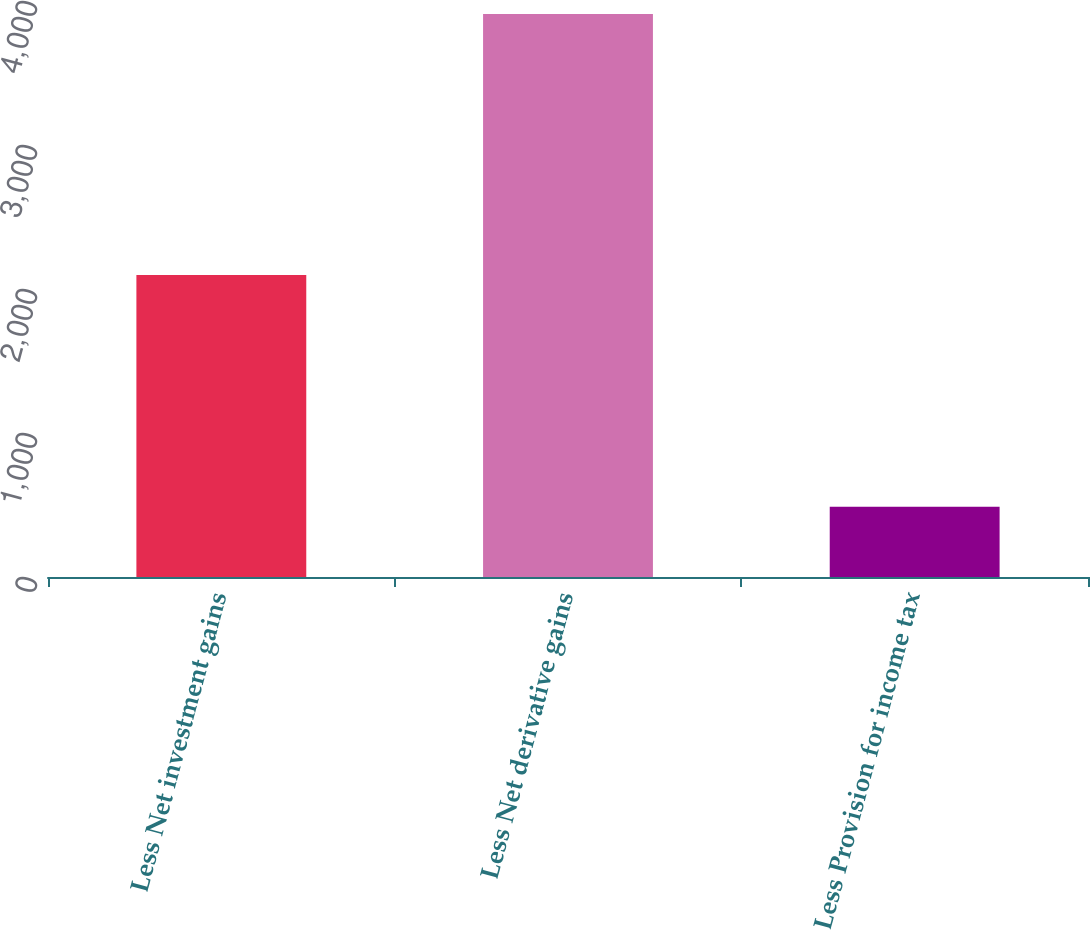Convert chart. <chart><loc_0><loc_0><loc_500><loc_500><bar_chart><fcel>Less Net investment gains<fcel>Less Net derivative gains<fcel>Less Provision for income tax<nl><fcel>2098<fcel>3910<fcel>488<nl></chart> 